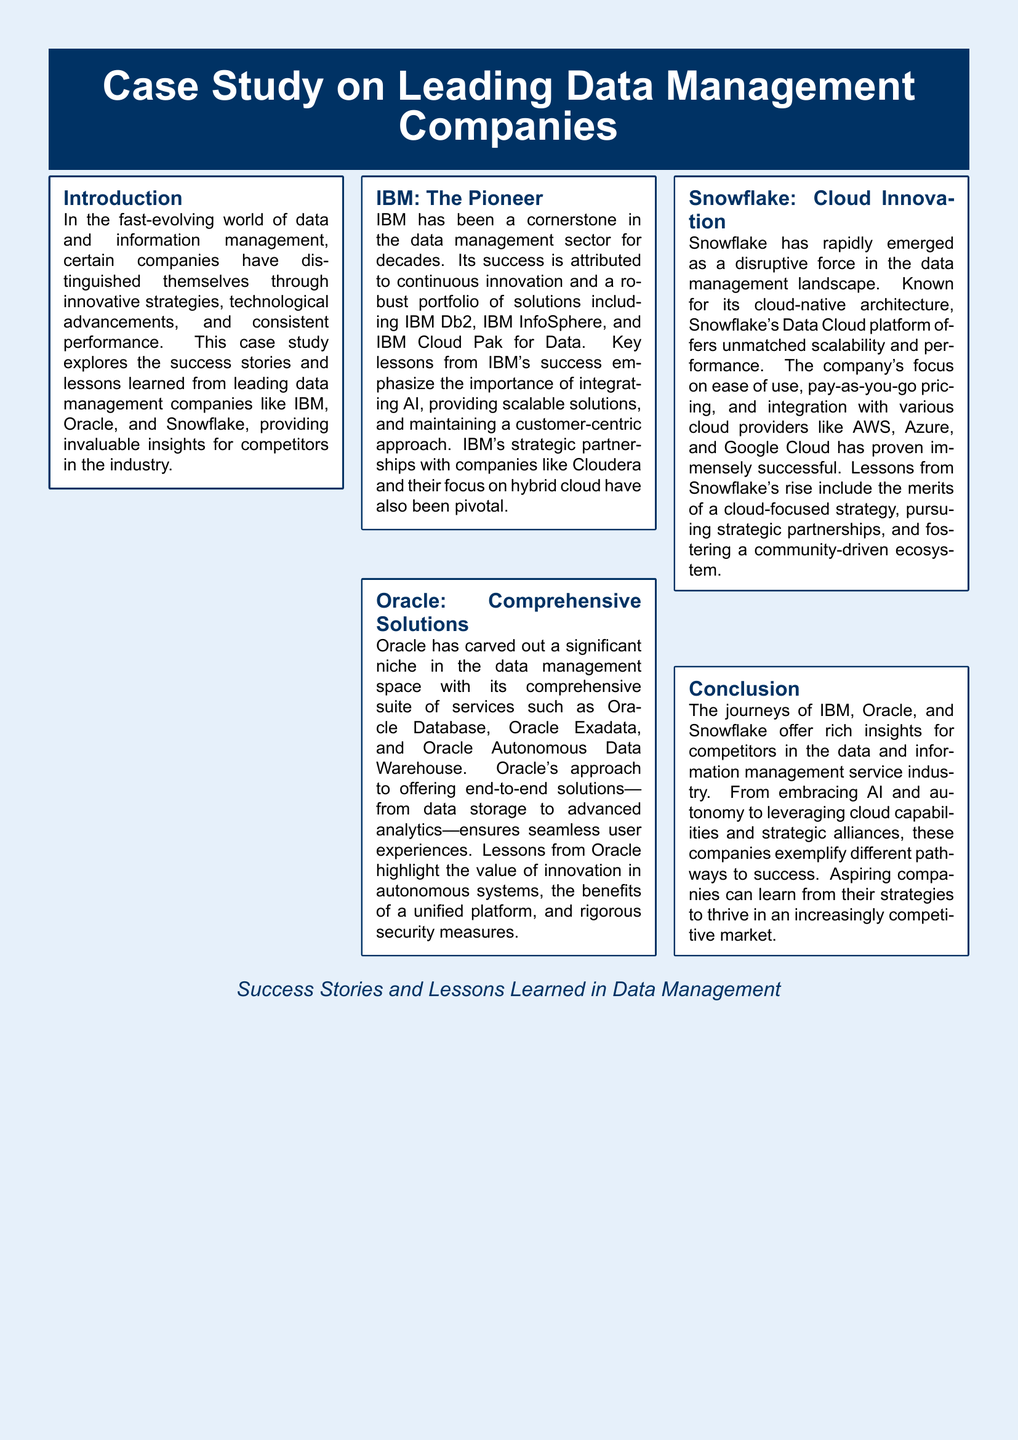What companies are highlighted in the case study? The document mentions IBM, Oracle, and Snowflake as the leading data management companies studied.
Answer: IBM, Oracle, Snowflake What is IBM's key focus area mentioned in the case study? The case study emphasizes IBM's focus on integrating AI and maintaining a customer-centric approach.
Answer: Integrating AI What unique architecture does Snowflake utilize? The document states that Snowflake is known for its cloud-native architecture.
Answer: Cloud-native architecture What approach does Oracle take in its service offerings? The case study notes Oracle's approach of offering end-to-end solutions from data storage to advanced analytics.
Answer: End-to-end solutions Which company emphasizes a pay-as-you-go pricing model? According to the document, Snowflake's focus includes a pay-as-you-go pricing model.
Answer: Snowflake What is a key lesson learned from IBM's success? The case study highlights the importance of providing scalable solutions as a key lesson from IBM.
Answer: Providing scalable solutions How have strategic partnerships contributed to IBM's success? The document mentions that IBM's strategic partnerships have been pivotal in its success.
Answer: Pivotal What does the conclusion of the document emphasize for aspiring companies? The conclusion emphasizes that aspiring companies can learn from the strategies of IBM, Oracle, and Snowflake.
Answer: Learn from strategies What type of document layout is used here? The document is presented in a magazine layout format.
Answer: Magazine layout 